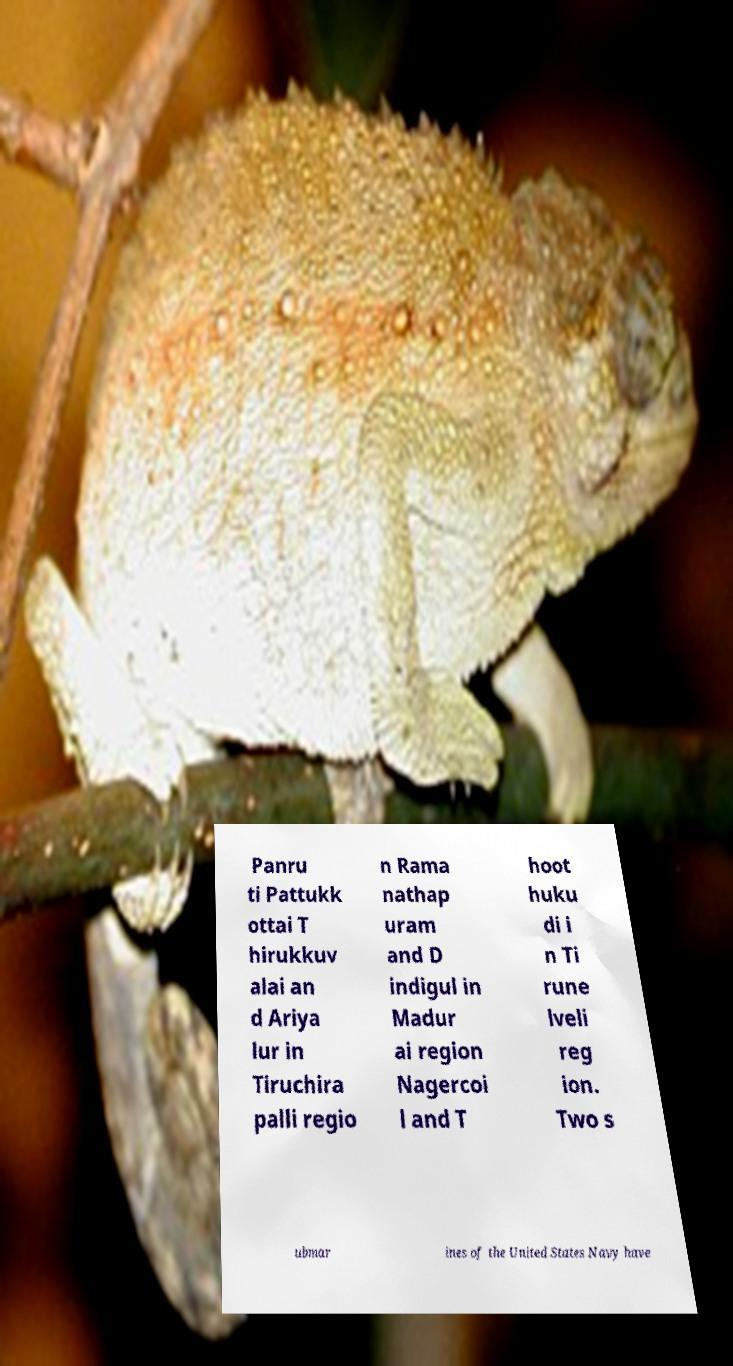Can you read and provide the text displayed in the image?This photo seems to have some interesting text. Can you extract and type it out for me? Panru ti Pattukk ottai T hirukkuv alai an d Ariya lur in Tiruchira palli regio n Rama nathap uram and D indigul in Madur ai region Nagercoi l and T hoot huku di i n Ti rune lveli reg ion. Two s ubmar ines of the United States Navy have 